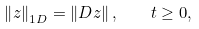Convert formula to latex. <formula><loc_0><loc_0><loc_500><loc_500>\left \| { z } \right \| _ { 1 D } = \left \| D { z } \right \| , \quad t \geq 0 ,</formula> 